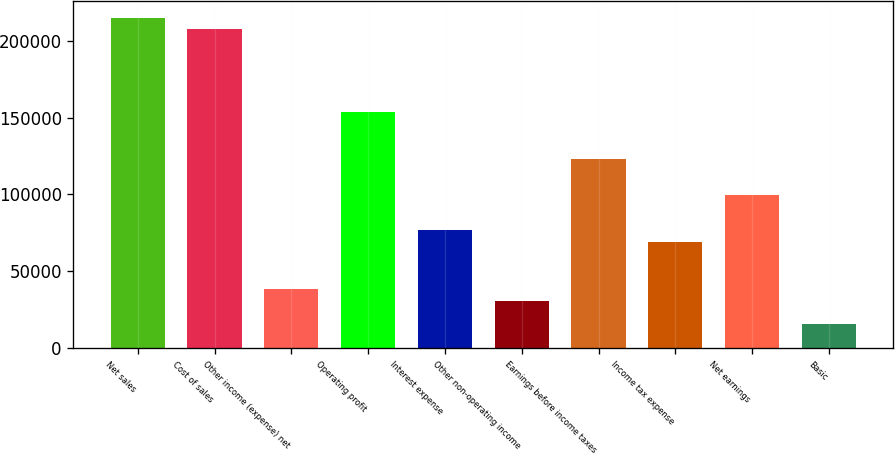Convert chart to OTSL. <chart><loc_0><loc_0><loc_500><loc_500><bar_chart><fcel>Net sales<fcel>Cost of sales<fcel>Other income (expense) net<fcel>Operating profit<fcel>Interest expense<fcel>Other non-operating income<fcel>Earnings before income taxes<fcel>Income tax expense<fcel>Net earnings<fcel>Basic<nl><fcel>215316<fcel>207626<fcel>38449.8<fcel>153797<fcel>76899<fcel>30759.9<fcel>123038<fcel>69209.1<fcel>99968.5<fcel>15380.3<nl></chart> 